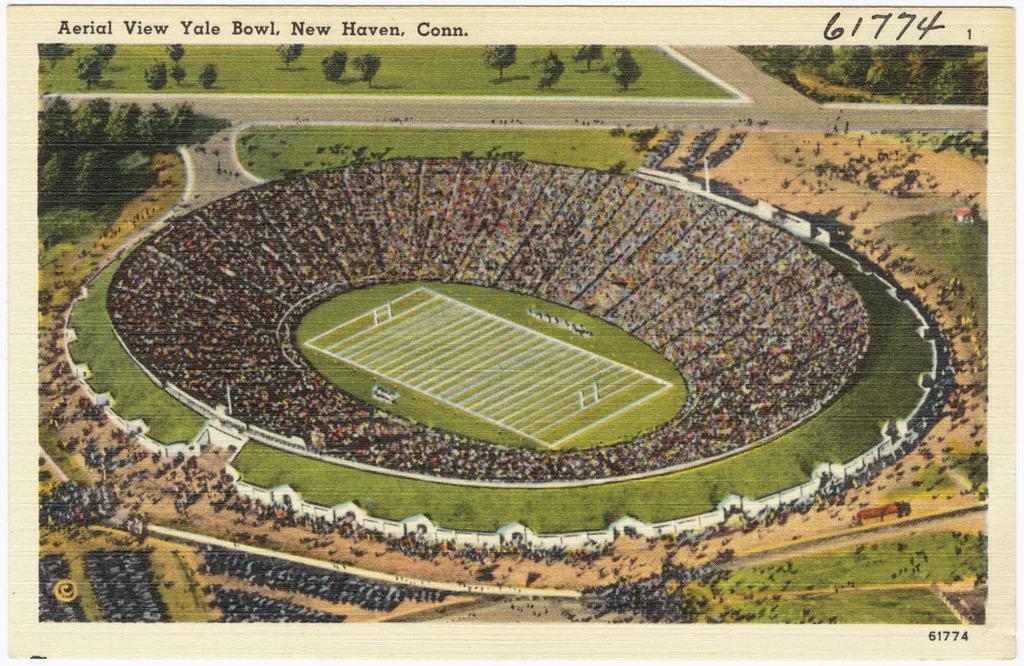In one or two sentences, can you explain what this image depicts? This image consists of a paper in which there is a picture of a stadium. To the left and right, there are trees. 